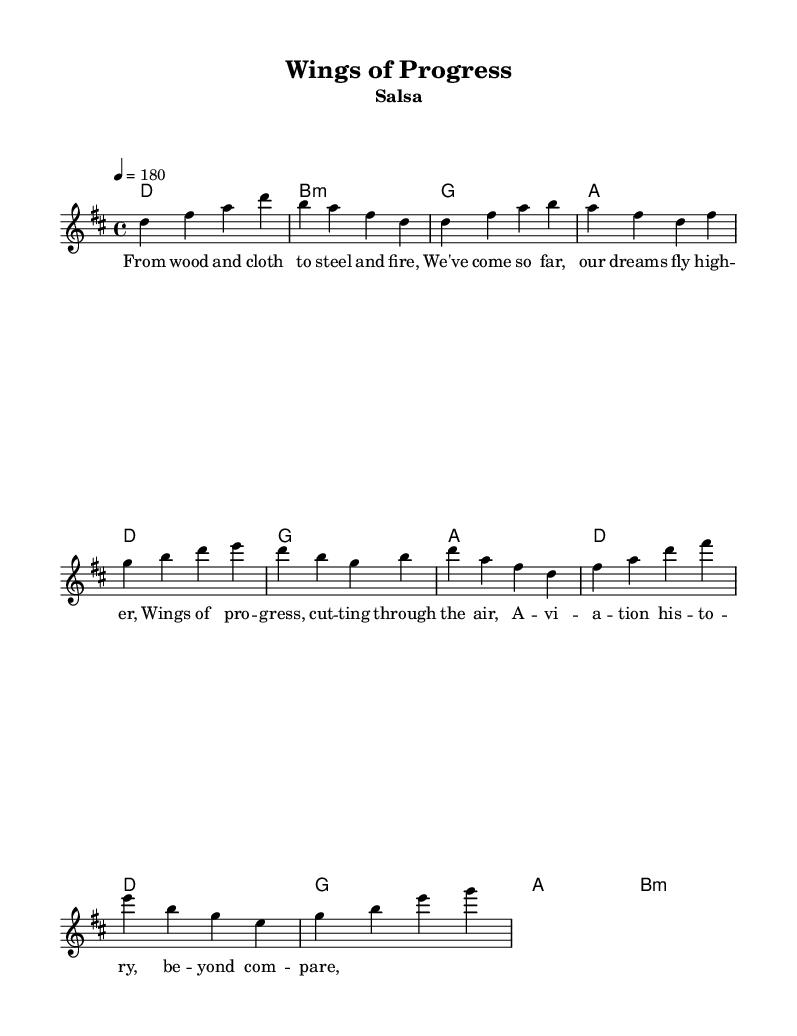What is the key signature of this music? The key signature is D major, which has two sharps (F# and C#). This can be identified from the `\key d \major` declaration in the global settings of the code.
Answer: D major What is the time signature of the music? The time signature is 4/4, which indicates four beats in a measure and a quarter note receives one beat. This is determined from the `\time 4/4` indication in the global settings.
Answer: 4/4 What is the tempo marking indicated in the score? The tempo is marked at quarter note equals 180 beats per minute, which indicates a fast-paced feel for the piece. This information comes from the `\tempo 4 = 180` directive in the code.
Answer: 180 How many measures are present in the chorus? The chorus section consists of six measures, as counted from the provided melody section. Specifically, the chorus has two lines, each consisting of three measures.
Answer: 6 What is the lyrical theme of the salsa track? The lyrical theme celebrates aviation history and progress in aircraft development, highlighted in the lyrics mentioning "Wings of Progress". The text discusses the advancement from traditional materials to modern innovations.
Answer: Aviation history Which chord is used in the introduction of the music? The chord used in the introduction is D major, followed by B minor, G major, and A major. This sequence indicates the harmonic foundation for the start of the piece. The information is present in the `\harmonies` section under the intro.
Answer: D major 